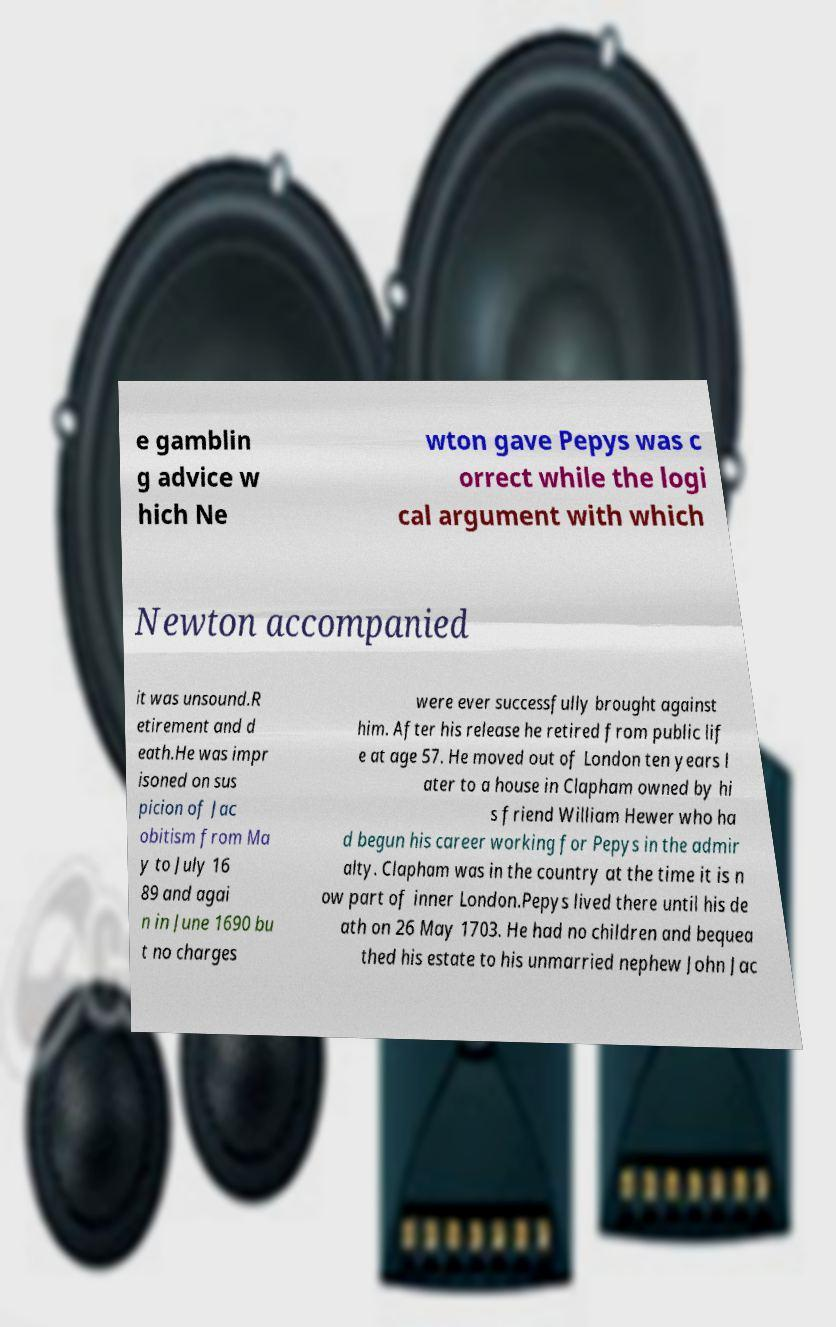Can you read and provide the text displayed in the image?This photo seems to have some interesting text. Can you extract and type it out for me? e gamblin g advice w hich Ne wton gave Pepys was c orrect while the logi cal argument with which Newton accompanied it was unsound.R etirement and d eath.He was impr isoned on sus picion of Jac obitism from Ma y to July 16 89 and agai n in June 1690 bu t no charges were ever successfully brought against him. After his release he retired from public lif e at age 57. He moved out of London ten years l ater to a house in Clapham owned by hi s friend William Hewer who ha d begun his career working for Pepys in the admir alty. Clapham was in the country at the time it is n ow part of inner London.Pepys lived there until his de ath on 26 May 1703. He had no children and bequea thed his estate to his unmarried nephew John Jac 